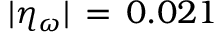Convert formula to latex. <formula><loc_0><loc_0><loc_500><loc_500>| \eta _ { \omega } | \, = \, 0 . 0 2 1</formula> 